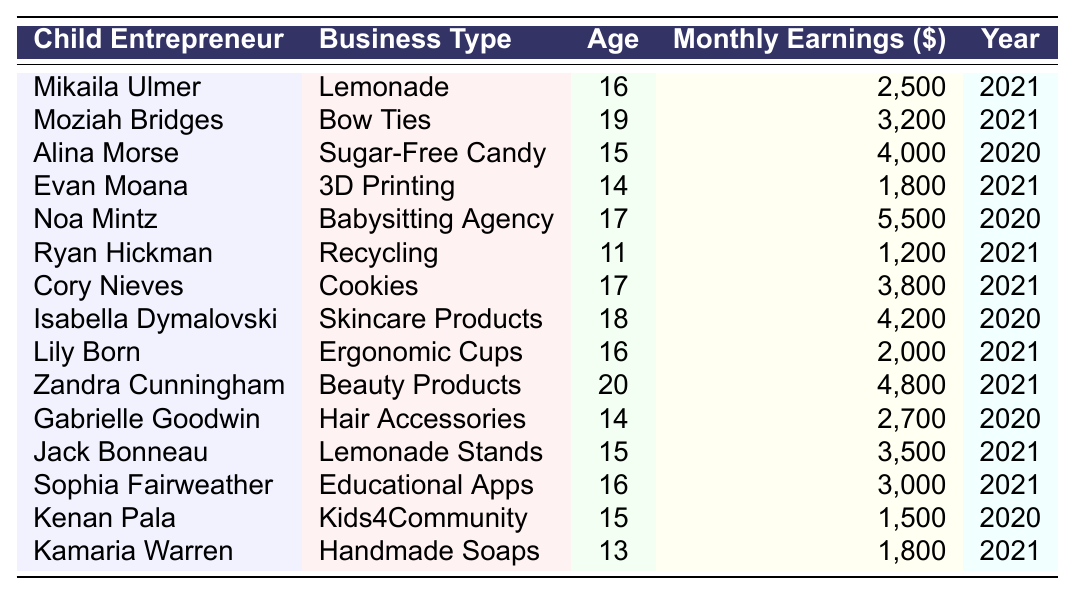What is the highest monthly earning listed in the table? The table shows various monthly earnings, and by examining the "Monthly Earnings ($)" column, the highest amount is identified as 5,500 from Noa Mintz's Babysitting Agency in 2020.
Answer: 5,500 How many child entrepreneurs have monthly earnings above $3,000? By checking the "Monthly Earnings ($)" column, the entrepreneurs with earnings above $3,000 are: Alina Morse (4,000), Noa Mintz (5,500), Isabella Dymalovski (4,200), Zandra Cunningham (4,800), Cory Nieves (3,800), and Jack Bonneau (3,500). That counts to six entrepreneurs.
Answer: 6 What is the average age of the child entrepreneurs listed in the table? First, we sum the ages: 16 + 19 + 15 + 14 + 17 + 11 + 17 + 18 + 16 + 20 + 14 + 15 + 16 + 15 + 13 =  244. Then, we divide by the number of entrepreneurs (15), resulting in an average age of 244 / 15 = 16.27, which can be rounded to approximately 16.3.
Answer: 16.3 Is there any child entrepreneur under the age of 13 in the table? Looking at the "Age" column, the lowest age listed is 11 (Ryan Hickman). Since 11 is less than 13, the answer is yes; there is a child entrepreneur under 13.
Answer: Yes What is the total monthly earning of the entrepreneurs whose businesses fall under food-related categories? Identifying food-related businesses in the table: Mikaila Ulmer (lemonade: 2,500), Moziah Bridges (bow ties: 3,200), Cory Nieves (cookies: 3,800), and Jack Bonneau (lemonade stands: 3,500). Their total earnings are 2,500 + 3,200 + 3,800 + 3,500 = 13,000.
Answer: 13,000 Which child entrepreneur has the lowest monthly earnings and how much did they earn? By comparing the values in the "Monthly Earnings ($)" column, Ryan Hickman has the lowest earning at 1,200.
Answer: Ryan Hickman, 1,200 Which business type has the highest earning, and what is that earning? From the table, Noa Mintz's Babysitting Agency has the highest earning of 5,500.
Answer: Babysitting Agency, 5,500 Are there any businesses in the table related to health or wellness? The table lists "Skincare Products" (Isabella Dymalovski) and "Handmade Soaps" (Kamaria Warren), which are generally considered health or wellness related. Therefore, the fact is true.
Answer: Yes What is the difference in monthly earnings between the highest and lowest earning child entrepreneurs? The highest earning is 5,500 from Noa Mintz and the lowest is 1,200 from Ryan Hickman. The difference is 5,500 - 1,200 = 4,300.
Answer: 4,300 How many entrepreneurs are aged 15, and what is their total earning? From the "Age" column, the entrepreneurs aged 15 are Alina Morse, Jack Bonneau, Kenan Pala, and Gabrielle Goodwin. Their total earnings are 4,000 + 3,500 + 1,500 + 2,700 = 11,700.
Answer: 4, 11,700 Which entrepreneur earns the most for their age, and what is the ratio of their earnings to their age? Noa Mintz earns 5,500 at the age of 17. The ratio of her earnings to age is 5,500 / 17 = 323.53.
Answer: Noa Mintz, 323.53 